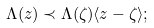<formula> <loc_0><loc_0><loc_500><loc_500>\Lambda ( z ) \prec \Lambda ( \zeta ) \langle z - \zeta \rangle ;</formula> 